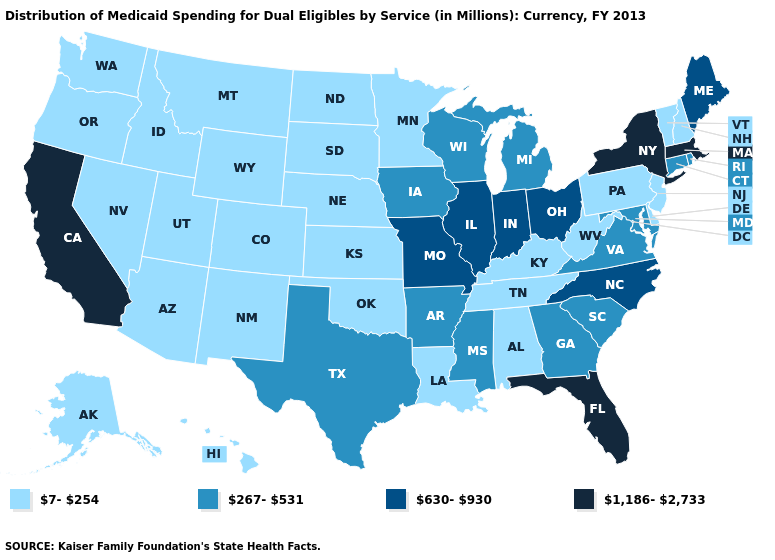Is the legend a continuous bar?
Keep it brief. No. Does the map have missing data?
Short answer required. No. Name the states that have a value in the range 7-254?
Be succinct. Alabama, Alaska, Arizona, Colorado, Delaware, Hawaii, Idaho, Kansas, Kentucky, Louisiana, Minnesota, Montana, Nebraska, Nevada, New Hampshire, New Jersey, New Mexico, North Dakota, Oklahoma, Oregon, Pennsylvania, South Dakota, Tennessee, Utah, Vermont, Washington, West Virginia, Wyoming. Does the map have missing data?
Write a very short answer. No. What is the value of Hawaii?
Answer briefly. 7-254. Among the states that border Oregon , does Washington have the highest value?
Keep it brief. No. What is the lowest value in states that border Rhode Island?
Answer briefly. 267-531. Which states have the lowest value in the MidWest?
Quick response, please. Kansas, Minnesota, Nebraska, North Dakota, South Dakota. Name the states that have a value in the range 1,186-2,733?
Be succinct. California, Florida, Massachusetts, New York. What is the highest value in the MidWest ?
Write a very short answer. 630-930. What is the value of Indiana?
Concise answer only. 630-930. Does Ohio have a lower value than California?
Answer briefly. Yes. What is the value of Oklahoma?
Concise answer only. 7-254. What is the highest value in the South ?
Short answer required. 1,186-2,733. What is the value of Virginia?
Concise answer only. 267-531. 